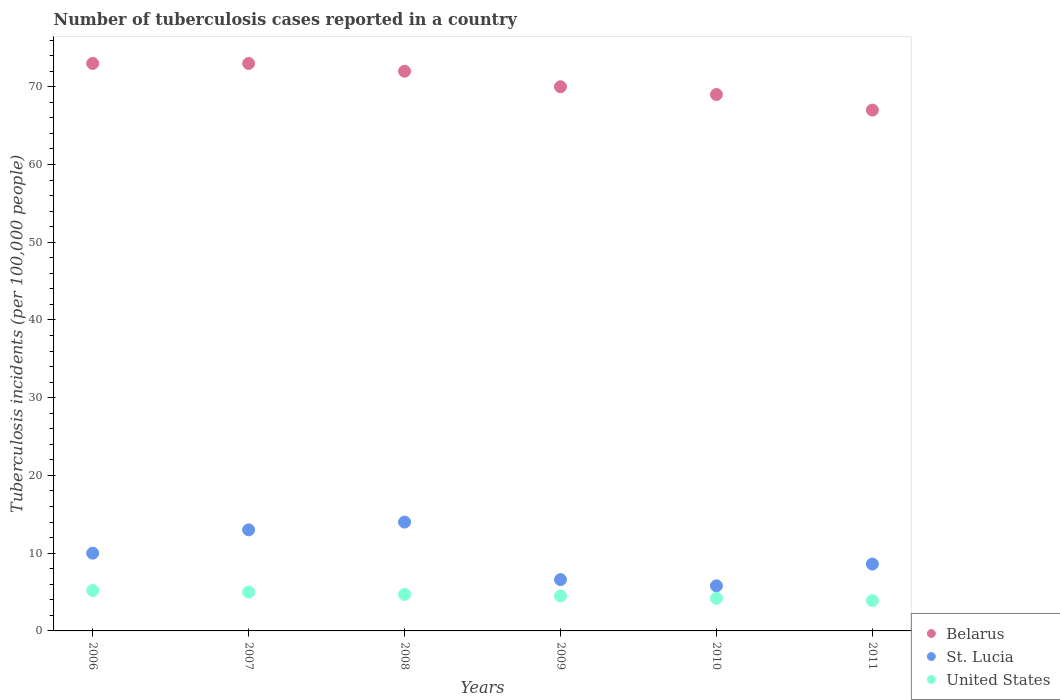Is the number of dotlines equal to the number of legend labels?
Keep it short and to the point. Yes. What is the number of tuberculosis cases reported in in Belarus in 2011?
Keep it short and to the point. 67. Across all years, what is the maximum number of tuberculosis cases reported in in United States?
Your answer should be very brief. 5.2. Across all years, what is the minimum number of tuberculosis cases reported in in United States?
Your answer should be compact. 3.9. In which year was the number of tuberculosis cases reported in in Belarus minimum?
Ensure brevity in your answer.  2011. What is the total number of tuberculosis cases reported in in St. Lucia in the graph?
Ensure brevity in your answer.  58. What is the difference between the number of tuberculosis cases reported in in St. Lucia in 2006 and that in 2007?
Provide a short and direct response. -3. What is the difference between the number of tuberculosis cases reported in in United States in 2006 and the number of tuberculosis cases reported in in Belarus in 2009?
Offer a terse response. -64.8. What is the average number of tuberculosis cases reported in in United States per year?
Provide a succinct answer. 4.58. In the year 2010, what is the difference between the number of tuberculosis cases reported in in Belarus and number of tuberculosis cases reported in in United States?
Your answer should be very brief. 64.8. What is the ratio of the number of tuberculosis cases reported in in United States in 2006 to that in 2008?
Offer a terse response. 1.11. Is the difference between the number of tuberculosis cases reported in in Belarus in 2008 and 2010 greater than the difference between the number of tuberculosis cases reported in in United States in 2008 and 2010?
Ensure brevity in your answer.  Yes. What is the difference between the highest and the second highest number of tuberculosis cases reported in in Belarus?
Offer a very short reply. 0. Does the number of tuberculosis cases reported in in Belarus monotonically increase over the years?
Give a very brief answer. No. Is the number of tuberculosis cases reported in in St. Lucia strictly less than the number of tuberculosis cases reported in in United States over the years?
Your response must be concise. No. How many years are there in the graph?
Provide a succinct answer. 6. What is the difference between two consecutive major ticks on the Y-axis?
Make the answer very short. 10. Are the values on the major ticks of Y-axis written in scientific E-notation?
Offer a terse response. No. Does the graph contain any zero values?
Offer a very short reply. No. Does the graph contain grids?
Your answer should be very brief. No. Where does the legend appear in the graph?
Make the answer very short. Bottom right. How many legend labels are there?
Provide a short and direct response. 3. How are the legend labels stacked?
Keep it short and to the point. Vertical. What is the title of the graph?
Your answer should be very brief. Number of tuberculosis cases reported in a country. What is the label or title of the X-axis?
Provide a short and direct response. Years. What is the label or title of the Y-axis?
Ensure brevity in your answer.  Tuberculosis incidents (per 100,0 people). What is the Tuberculosis incidents (per 100,000 people) of Belarus in 2006?
Your answer should be compact. 73. What is the Tuberculosis incidents (per 100,000 people) in St. Lucia in 2007?
Provide a short and direct response. 13. What is the Tuberculosis incidents (per 100,000 people) in St. Lucia in 2008?
Offer a terse response. 14. What is the Tuberculosis incidents (per 100,000 people) of Belarus in 2010?
Give a very brief answer. 69. What is the Tuberculosis incidents (per 100,000 people) in St. Lucia in 2010?
Offer a terse response. 5.8. What is the Tuberculosis incidents (per 100,000 people) of United States in 2010?
Keep it short and to the point. 4.2. What is the Tuberculosis incidents (per 100,000 people) in St. Lucia in 2011?
Make the answer very short. 8.6. Across all years, what is the maximum Tuberculosis incidents (per 100,000 people) of United States?
Ensure brevity in your answer.  5.2. Across all years, what is the minimum Tuberculosis incidents (per 100,000 people) in Belarus?
Your response must be concise. 67. Across all years, what is the minimum Tuberculosis incidents (per 100,000 people) in St. Lucia?
Your answer should be very brief. 5.8. Across all years, what is the minimum Tuberculosis incidents (per 100,000 people) of United States?
Ensure brevity in your answer.  3.9. What is the total Tuberculosis incidents (per 100,000 people) in Belarus in the graph?
Offer a terse response. 424. What is the total Tuberculosis incidents (per 100,000 people) of St. Lucia in the graph?
Ensure brevity in your answer.  58. What is the difference between the Tuberculosis incidents (per 100,000 people) in Belarus in 2006 and that in 2007?
Provide a short and direct response. 0. What is the difference between the Tuberculosis incidents (per 100,000 people) of St. Lucia in 2006 and that in 2007?
Provide a succinct answer. -3. What is the difference between the Tuberculosis incidents (per 100,000 people) of United States in 2006 and that in 2007?
Your response must be concise. 0.2. What is the difference between the Tuberculosis incidents (per 100,000 people) of St. Lucia in 2006 and that in 2008?
Offer a terse response. -4. What is the difference between the Tuberculosis incidents (per 100,000 people) of United States in 2006 and that in 2008?
Provide a short and direct response. 0.5. What is the difference between the Tuberculosis incidents (per 100,000 people) of Belarus in 2006 and that in 2009?
Your response must be concise. 3. What is the difference between the Tuberculosis incidents (per 100,000 people) in St. Lucia in 2006 and that in 2009?
Keep it short and to the point. 3.4. What is the difference between the Tuberculosis incidents (per 100,000 people) of Belarus in 2006 and that in 2011?
Give a very brief answer. 6. What is the difference between the Tuberculosis incidents (per 100,000 people) in United States in 2006 and that in 2011?
Your answer should be very brief. 1.3. What is the difference between the Tuberculosis incidents (per 100,000 people) in Belarus in 2007 and that in 2008?
Keep it short and to the point. 1. What is the difference between the Tuberculosis incidents (per 100,000 people) in St. Lucia in 2007 and that in 2008?
Provide a short and direct response. -1. What is the difference between the Tuberculosis incidents (per 100,000 people) of Belarus in 2007 and that in 2009?
Your response must be concise. 3. What is the difference between the Tuberculosis incidents (per 100,000 people) of St. Lucia in 2007 and that in 2009?
Give a very brief answer. 6.4. What is the difference between the Tuberculosis incidents (per 100,000 people) in United States in 2007 and that in 2009?
Make the answer very short. 0.5. What is the difference between the Tuberculosis incidents (per 100,000 people) of United States in 2007 and that in 2010?
Provide a short and direct response. 0.8. What is the difference between the Tuberculosis incidents (per 100,000 people) in St. Lucia in 2008 and that in 2009?
Your response must be concise. 7.4. What is the difference between the Tuberculosis incidents (per 100,000 people) in United States in 2008 and that in 2009?
Give a very brief answer. 0.2. What is the difference between the Tuberculosis incidents (per 100,000 people) in Belarus in 2008 and that in 2010?
Provide a succinct answer. 3. What is the difference between the Tuberculosis incidents (per 100,000 people) in United States in 2008 and that in 2010?
Your answer should be very brief. 0.5. What is the difference between the Tuberculosis incidents (per 100,000 people) of St. Lucia in 2008 and that in 2011?
Your answer should be compact. 5.4. What is the difference between the Tuberculosis incidents (per 100,000 people) in Belarus in 2009 and that in 2010?
Give a very brief answer. 1. What is the difference between the Tuberculosis incidents (per 100,000 people) of St. Lucia in 2009 and that in 2011?
Offer a very short reply. -2. What is the difference between the Tuberculosis incidents (per 100,000 people) of United States in 2009 and that in 2011?
Provide a succinct answer. 0.6. What is the difference between the Tuberculosis incidents (per 100,000 people) of St. Lucia in 2010 and that in 2011?
Your answer should be very brief. -2.8. What is the difference between the Tuberculosis incidents (per 100,000 people) in United States in 2010 and that in 2011?
Provide a short and direct response. 0.3. What is the difference between the Tuberculosis incidents (per 100,000 people) of Belarus in 2006 and the Tuberculosis incidents (per 100,000 people) of United States in 2008?
Provide a short and direct response. 68.3. What is the difference between the Tuberculosis incidents (per 100,000 people) of St. Lucia in 2006 and the Tuberculosis incidents (per 100,000 people) of United States in 2008?
Ensure brevity in your answer.  5.3. What is the difference between the Tuberculosis incidents (per 100,000 people) of Belarus in 2006 and the Tuberculosis incidents (per 100,000 people) of St. Lucia in 2009?
Give a very brief answer. 66.4. What is the difference between the Tuberculosis incidents (per 100,000 people) of Belarus in 2006 and the Tuberculosis incidents (per 100,000 people) of United States in 2009?
Give a very brief answer. 68.5. What is the difference between the Tuberculosis incidents (per 100,000 people) in St. Lucia in 2006 and the Tuberculosis incidents (per 100,000 people) in United States in 2009?
Ensure brevity in your answer.  5.5. What is the difference between the Tuberculosis incidents (per 100,000 people) of Belarus in 2006 and the Tuberculosis incidents (per 100,000 people) of St. Lucia in 2010?
Your response must be concise. 67.2. What is the difference between the Tuberculosis incidents (per 100,000 people) in Belarus in 2006 and the Tuberculosis incidents (per 100,000 people) in United States in 2010?
Your response must be concise. 68.8. What is the difference between the Tuberculosis incidents (per 100,000 people) of St. Lucia in 2006 and the Tuberculosis incidents (per 100,000 people) of United States in 2010?
Make the answer very short. 5.8. What is the difference between the Tuberculosis incidents (per 100,000 people) in Belarus in 2006 and the Tuberculosis incidents (per 100,000 people) in St. Lucia in 2011?
Provide a succinct answer. 64.4. What is the difference between the Tuberculosis incidents (per 100,000 people) in Belarus in 2006 and the Tuberculosis incidents (per 100,000 people) in United States in 2011?
Your answer should be compact. 69.1. What is the difference between the Tuberculosis incidents (per 100,000 people) of Belarus in 2007 and the Tuberculosis incidents (per 100,000 people) of United States in 2008?
Keep it short and to the point. 68.3. What is the difference between the Tuberculosis incidents (per 100,000 people) in St. Lucia in 2007 and the Tuberculosis incidents (per 100,000 people) in United States in 2008?
Your answer should be compact. 8.3. What is the difference between the Tuberculosis incidents (per 100,000 people) of Belarus in 2007 and the Tuberculosis incidents (per 100,000 people) of St. Lucia in 2009?
Provide a short and direct response. 66.4. What is the difference between the Tuberculosis incidents (per 100,000 people) of Belarus in 2007 and the Tuberculosis incidents (per 100,000 people) of United States in 2009?
Your answer should be compact. 68.5. What is the difference between the Tuberculosis incidents (per 100,000 people) in Belarus in 2007 and the Tuberculosis incidents (per 100,000 people) in St. Lucia in 2010?
Your response must be concise. 67.2. What is the difference between the Tuberculosis incidents (per 100,000 people) in Belarus in 2007 and the Tuberculosis incidents (per 100,000 people) in United States in 2010?
Provide a succinct answer. 68.8. What is the difference between the Tuberculosis incidents (per 100,000 people) of Belarus in 2007 and the Tuberculosis incidents (per 100,000 people) of St. Lucia in 2011?
Your response must be concise. 64.4. What is the difference between the Tuberculosis incidents (per 100,000 people) of Belarus in 2007 and the Tuberculosis incidents (per 100,000 people) of United States in 2011?
Offer a terse response. 69.1. What is the difference between the Tuberculosis incidents (per 100,000 people) in Belarus in 2008 and the Tuberculosis incidents (per 100,000 people) in St. Lucia in 2009?
Provide a short and direct response. 65.4. What is the difference between the Tuberculosis incidents (per 100,000 people) of Belarus in 2008 and the Tuberculosis incidents (per 100,000 people) of United States in 2009?
Your answer should be very brief. 67.5. What is the difference between the Tuberculosis incidents (per 100,000 people) in Belarus in 2008 and the Tuberculosis incidents (per 100,000 people) in St. Lucia in 2010?
Ensure brevity in your answer.  66.2. What is the difference between the Tuberculosis incidents (per 100,000 people) of Belarus in 2008 and the Tuberculosis incidents (per 100,000 people) of United States in 2010?
Provide a short and direct response. 67.8. What is the difference between the Tuberculosis incidents (per 100,000 people) of Belarus in 2008 and the Tuberculosis incidents (per 100,000 people) of St. Lucia in 2011?
Keep it short and to the point. 63.4. What is the difference between the Tuberculosis incidents (per 100,000 people) in Belarus in 2008 and the Tuberculosis incidents (per 100,000 people) in United States in 2011?
Your response must be concise. 68.1. What is the difference between the Tuberculosis incidents (per 100,000 people) in Belarus in 2009 and the Tuberculosis incidents (per 100,000 people) in St. Lucia in 2010?
Provide a succinct answer. 64.2. What is the difference between the Tuberculosis incidents (per 100,000 people) in Belarus in 2009 and the Tuberculosis incidents (per 100,000 people) in United States in 2010?
Ensure brevity in your answer.  65.8. What is the difference between the Tuberculosis incidents (per 100,000 people) in St. Lucia in 2009 and the Tuberculosis incidents (per 100,000 people) in United States in 2010?
Your answer should be very brief. 2.4. What is the difference between the Tuberculosis incidents (per 100,000 people) in Belarus in 2009 and the Tuberculosis incidents (per 100,000 people) in St. Lucia in 2011?
Provide a short and direct response. 61.4. What is the difference between the Tuberculosis incidents (per 100,000 people) of Belarus in 2009 and the Tuberculosis incidents (per 100,000 people) of United States in 2011?
Offer a very short reply. 66.1. What is the difference between the Tuberculosis incidents (per 100,000 people) of St. Lucia in 2009 and the Tuberculosis incidents (per 100,000 people) of United States in 2011?
Provide a succinct answer. 2.7. What is the difference between the Tuberculosis incidents (per 100,000 people) in Belarus in 2010 and the Tuberculosis incidents (per 100,000 people) in St. Lucia in 2011?
Offer a very short reply. 60.4. What is the difference between the Tuberculosis incidents (per 100,000 people) in Belarus in 2010 and the Tuberculosis incidents (per 100,000 people) in United States in 2011?
Your response must be concise. 65.1. What is the average Tuberculosis incidents (per 100,000 people) in Belarus per year?
Give a very brief answer. 70.67. What is the average Tuberculosis incidents (per 100,000 people) in St. Lucia per year?
Make the answer very short. 9.67. What is the average Tuberculosis incidents (per 100,000 people) of United States per year?
Keep it short and to the point. 4.58. In the year 2006, what is the difference between the Tuberculosis incidents (per 100,000 people) of Belarus and Tuberculosis incidents (per 100,000 people) of United States?
Your response must be concise. 67.8. In the year 2006, what is the difference between the Tuberculosis incidents (per 100,000 people) in St. Lucia and Tuberculosis incidents (per 100,000 people) in United States?
Make the answer very short. 4.8. In the year 2007, what is the difference between the Tuberculosis incidents (per 100,000 people) in Belarus and Tuberculosis incidents (per 100,000 people) in United States?
Give a very brief answer. 68. In the year 2008, what is the difference between the Tuberculosis incidents (per 100,000 people) of Belarus and Tuberculosis incidents (per 100,000 people) of United States?
Offer a very short reply. 67.3. In the year 2009, what is the difference between the Tuberculosis incidents (per 100,000 people) in Belarus and Tuberculosis incidents (per 100,000 people) in St. Lucia?
Provide a short and direct response. 63.4. In the year 2009, what is the difference between the Tuberculosis incidents (per 100,000 people) in Belarus and Tuberculosis incidents (per 100,000 people) in United States?
Offer a terse response. 65.5. In the year 2010, what is the difference between the Tuberculosis incidents (per 100,000 people) in Belarus and Tuberculosis incidents (per 100,000 people) in St. Lucia?
Offer a very short reply. 63.2. In the year 2010, what is the difference between the Tuberculosis incidents (per 100,000 people) of Belarus and Tuberculosis incidents (per 100,000 people) of United States?
Keep it short and to the point. 64.8. In the year 2011, what is the difference between the Tuberculosis incidents (per 100,000 people) of Belarus and Tuberculosis incidents (per 100,000 people) of St. Lucia?
Ensure brevity in your answer.  58.4. In the year 2011, what is the difference between the Tuberculosis incidents (per 100,000 people) in Belarus and Tuberculosis incidents (per 100,000 people) in United States?
Make the answer very short. 63.1. What is the ratio of the Tuberculosis incidents (per 100,000 people) of St. Lucia in 2006 to that in 2007?
Make the answer very short. 0.77. What is the ratio of the Tuberculosis incidents (per 100,000 people) of United States in 2006 to that in 2007?
Give a very brief answer. 1.04. What is the ratio of the Tuberculosis incidents (per 100,000 people) of Belarus in 2006 to that in 2008?
Your answer should be very brief. 1.01. What is the ratio of the Tuberculosis incidents (per 100,000 people) of United States in 2006 to that in 2008?
Provide a short and direct response. 1.11. What is the ratio of the Tuberculosis incidents (per 100,000 people) of Belarus in 2006 to that in 2009?
Give a very brief answer. 1.04. What is the ratio of the Tuberculosis incidents (per 100,000 people) in St. Lucia in 2006 to that in 2009?
Offer a terse response. 1.52. What is the ratio of the Tuberculosis incidents (per 100,000 people) of United States in 2006 to that in 2009?
Your response must be concise. 1.16. What is the ratio of the Tuberculosis incidents (per 100,000 people) in Belarus in 2006 to that in 2010?
Give a very brief answer. 1.06. What is the ratio of the Tuberculosis incidents (per 100,000 people) of St. Lucia in 2006 to that in 2010?
Your answer should be compact. 1.72. What is the ratio of the Tuberculosis incidents (per 100,000 people) in United States in 2006 to that in 2010?
Your answer should be compact. 1.24. What is the ratio of the Tuberculosis incidents (per 100,000 people) of Belarus in 2006 to that in 2011?
Keep it short and to the point. 1.09. What is the ratio of the Tuberculosis incidents (per 100,000 people) in St. Lucia in 2006 to that in 2011?
Give a very brief answer. 1.16. What is the ratio of the Tuberculosis incidents (per 100,000 people) in United States in 2006 to that in 2011?
Your response must be concise. 1.33. What is the ratio of the Tuberculosis incidents (per 100,000 people) in Belarus in 2007 to that in 2008?
Your answer should be very brief. 1.01. What is the ratio of the Tuberculosis incidents (per 100,000 people) in United States in 2007 to that in 2008?
Keep it short and to the point. 1.06. What is the ratio of the Tuberculosis incidents (per 100,000 people) in Belarus in 2007 to that in 2009?
Your response must be concise. 1.04. What is the ratio of the Tuberculosis incidents (per 100,000 people) of St. Lucia in 2007 to that in 2009?
Give a very brief answer. 1.97. What is the ratio of the Tuberculosis incidents (per 100,000 people) in Belarus in 2007 to that in 2010?
Your answer should be very brief. 1.06. What is the ratio of the Tuberculosis incidents (per 100,000 people) in St. Lucia in 2007 to that in 2010?
Offer a terse response. 2.24. What is the ratio of the Tuberculosis incidents (per 100,000 people) in United States in 2007 to that in 2010?
Give a very brief answer. 1.19. What is the ratio of the Tuberculosis incidents (per 100,000 people) of Belarus in 2007 to that in 2011?
Provide a succinct answer. 1.09. What is the ratio of the Tuberculosis incidents (per 100,000 people) in St. Lucia in 2007 to that in 2011?
Offer a very short reply. 1.51. What is the ratio of the Tuberculosis incidents (per 100,000 people) in United States in 2007 to that in 2011?
Make the answer very short. 1.28. What is the ratio of the Tuberculosis incidents (per 100,000 people) in Belarus in 2008 to that in 2009?
Ensure brevity in your answer.  1.03. What is the ratio of the Tuberculosis incidents (per 100,000 people) in St. Lucia in 2008 to that in 2009?
Your answer should be compact. 2.12. What is the ratio of the Tuberculosis incidents (per 100,000 people) of United States in 2008 to that in 2009?
Your answer should be very brief. 1.04. What is the ratio of the Tuberculosis incidents (per 100,000 people) of Belarus in 2008 to that in 2010?
Make the answer very short. 1.04. What is the ratio of the Tuberculosis incidents (per 100,000 people) of St. Lucia in 2008 to that in 2010?
Provide a succinct answer. 2.41. What is the ratio of the Tuberculosis incidents (per 100,000 people) of United States in 2008 to that in 2010?
Your answer should be very brief. 1.12. What is the ratio of the Tuberculosis incidents (per 100,000 people) in Belarus in 2008 to that in 2011?
Make the answer very short. 1.07. What is the ratio of the Tuberculosis incidents (per 100,000 people) in St. Lucia in 2008 to that in 2011?
Keep it short and to the point. 1.63. What is the ratio of the Tuberculosis incidents (per 100,000 people) in United States in 2008 to that in 2011?
Offer a very short reply. 1.21. What is the ratio of the Tuberculosis incidents (per 100,000 people) of Belarus in 2009 to that in 2010?
Make the answer very short. 1.01. What is the ratio of the Tuberculosis incidents (per 100,000 people) in St. Lucia in 2009 to that in 2010?
Provide a short and direct response. 1.14. What is the ratio of the Tuberculosis incidents (per 100,000 people) in United States in 2009 to that in 2010?
Offer a very short reply. 1.07. What is the ratio of the Tuberculosis incidents (per 100,000 people) in Belarus in 2009 to that in 2011?
Give a very brief answer. 1.04. What is the ratio of the Tuberculosis incidents (per 100,000 people) in St. Lucia in 2009 to that in 2011?
Your answer should be compact. 0.77. What is the ratio of the Tuberculosis incidents (per 100,000 people) of United States in 2009 to that in 2011?
Give a very brief answer. 1.15. What is the ratio of the Tuberculosis incidents (per 100,000 people) of Belarus in 2010 to that in 2011?
Your answer should be compact. 1.03. What is the ratio of the Tuberculosis incidents (per 100,000 people) of St. Lucia in 2010 to that in 2011?
Offer a terse response. 0.67. What is the difference between the highest and the second highest Tuberculosis incidents (per 100,000 people) in Belarus?
Offer a terse response. 0. What is the difference between the highest and the second highest Tuberculosis incidents (per 100,000 people) in St. Lucia?
Offer a very short reply. 1. What is the difference between the highest and the second highest Tuberculosis incidents (per 100,000 people) of United States?
Offer a terse response. 0.2. What is the difference between the highest and the lowest Tuberculosis incidents (per 100,000 people) of Belarus?
Provide a succinct answer. 6. What is the difference between the highest and the lowest Tuberculosis incidents (per 100,000 people) in United States?
Your answer should be very brief. 1.3. 